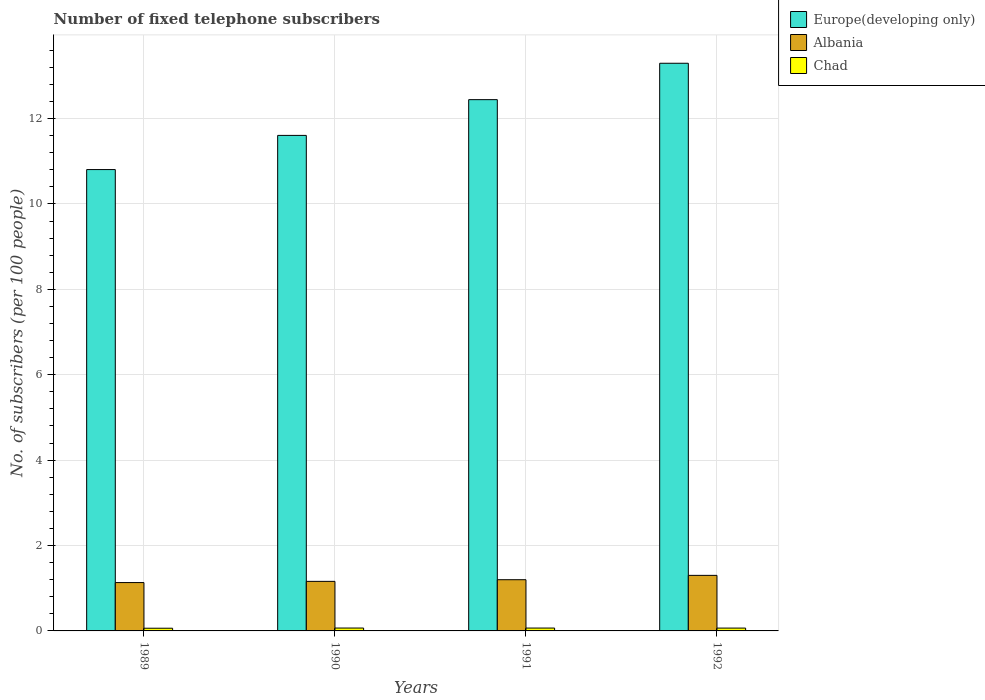How many groups of bars are there?
Offer a terse response. 4. Are the number of bars per tick equal to the number of legend labels?
Provide a short and direct response. Yes. Are the number of bars on each tick of the X-axis equal?
Offer a very short reply. Yes. How many bars are there on the 3rd tick from the left?
Your answer should be very brief. 3. What is the number of fixed telephone subscribers in Albania in 1990?
Your answer should be compact. 1.16. Across all years, what is the maximum number of fixed telephone subscribers in Europe(developing only)?
Provide a succinct answer. 13.29. Across all years, what is the minimum number of fixed telephone subscribers in Chad?
Offer a terse response. 0.06. What is the total number of fixed telephone subscribers in Chad in the graph?
Make the answer very short. 0.26. What is the difference between the number of fixed telephone subscribers in Albania in 1989 and that in 1990?
Give a very brief answer. -0.03. What is the difference between the number of fixed telephone subscribers in Albania in 1991 and the number of fixed telephone subscribers in Chad in 1990?
Offer a terse response. 1.13. What is the average number of fixed telephone subscribers in Europe(developing only) per year?
Your answer should be very brief. 12.04. In the year 1989, what is the difference between the number of fixed telephone subscribers in Albania and number of fixed telephone subscribers in Europe(developing only)?
Offer a terse response. -9.67. In how many years, is the number of fixed telephone subscribers in Chad greater than 2.4?
Make the answer very short. 0. What is the ratio of the number of fixed telephone subscribers in Albania in 1991 to that in 1992?
Your response must be concise. 0.92. Is the difference between the number of fixed telephone subscribers in Albania in 1989 and 1991 greater than the difference between the number of fixed telephone subscribers in Europe(developing only) in 1989 and 1991?
Keep it short and to the point. Yes. What is the difference between the highest and the second highest number of fixed telephone subscribers in Europe(developing only)?
Provide a short and direct response. 0.85. What is the difference between the highest and the lowest number of fixed telephone subscribers in Chad?
Offer a very short reply. 0. What does the 3rd bar from the left in 1989 represents?
Provide a short and direct response. Chad. What does the 1st bar from the right in 1990 represents?
Your answer should be compact. Chad. Is it the case that in every year, the sum of the number of fixed telephone subscribers in Chad and number of fixed telephone subscribers in Europe(developing only) is greater than the number of fixed telephone subscribers in Albania?
Offer a terse response. Yes. How many years are there in the graph?
Offer a terse response. 4. What is the difference between two consecutive major ticks on the Y-axis?
Make the answer very short. 2. Does the graph contain any zero values?
Ensure brevity in your answer.  No. Where does the legend appear in the graph?
Give a very brief answer. Top right. What is the title of the graph?
Make the answer very short. Number of fixed telephone subscribers. Does "Cabo Verde" appear as one of the legend labels in the graph?
Your answer should be very brief. No. What is the label or title of the Y-axis?
Your answer should be very brief. No. of subscribers (per 100 people). What is the No. of subscribers (per 100 people) of Europe(developing only) in 1989?
Keep it short and to the point. 10.8. What is the No. of subscribers (per 100 people) in Albania in 1989?
Offer a very short reply. 1.13. What is the No. of subscribers (per 100 people) of Chad in 1989?
Your answer should be compact. 0.06. What is the No. of subscribers (per 100 people) in Europe(developing only) in 1990?
Provide a short and direct response. 11.61. What is the No. of subscribers (per 100 people) of Albania in 1990?
Your response must be concise. 1.16. What is the No. of subscribers (per 100 people) in Chad in 1990?
Give a very brief answer. 0.07. What is the No. of subscribers (per 100 people) of Europe(developing only) in 1991?
Give a very brief answer. 12.44. What is the No. of subscribers (per 100 people) of Albania in 1991?
Your answer should be compact. 1.2. What is the No. of subscribers (per 100 people) of Chad in 1991?
Give a very brief answer. 0.07. What is the No. of subscribers (per 100 people) in Europe(developing only) in 1992?
Offer a terse response. 13.29. What is the No. of subscribers (per 100 people) in Albania in 1992?
Provide a short and direct response. 1.3. What is the No. of subscribers (per 100 people) in Chad in 1992?
Your answer should be compact. 0.07. Across all years, what is the maximum No. of subscribers (per 100 people) in Europe(developing only)?
Provide a succinct answer. 13.29. Across all years, what is the maximum No. of subscribers (per 100 people) in Albania?
Give a very brief answer. 1.3. Across all years, what is the maximum No. of subscribers (per 100 people) in Chad?
Give a very brief answer. 0.07. Across all years, what is the minimum No. of subscribers (per 100 people) in Europe(developing only)?
Provide a succinct answer. 10.8. Across all years, what is the minimum No. of subscribers (per 100 people) in Albania?
Keep it short and to the point. 1.13. Across all years, what is the minimum No. of subscribers (per 100 people) in Chad?
Give a very brief answer. 0.06. What is the total No. of subscribers (per 100 people) in Europe(developing only) in the graph?
Keep it short and to the point. 48.15. What is the total No. of subscribers (per 100 people) in Albania in the graph?
Offer a terse response. 4.79. What is the total No. of subscribers (per 100 people) in Chad in the graph?
Offer a very short reply. 0.26. What is the difference between the No. of subscribers (per 100 people) in Europe(developing only) in 1989 and that in 1990?
Keep it short and to the point. -0.8. What is the difference between the No. of subscribers (per 100 people) in Albania in 1989 and that in 1990?
Give a very brief answer. -0.03. What is the difference between the No. of subscribers (per 100 people) in Chad in 1989 and that in 1990?
Your answer should be compact. -0. What is the difference between the No. of subscribers (per 100 people) in Europe(developing only) in 1989 and that in 1991?
Make the answer very short. -1.64. What is the difference between the No. of subscribers (per 100 people) of Albania in 1989 and that in 1991?
Offer a very short reply. -0.07. What is the difference between the No. of subscribers (per 100 people) of Chad in 1989 and that in 1991?
Ensure brevity in your answer.  -0. What is the difference between the No. of subscribers (per 100 people) of Europe(developing only) in 1989 and that in 1992?
Your answer should be very brief. -2.49. What is the difference between the No. of subscribers (per 100 people) of Albania in 1989 and that in 1992?
Your answer should be very brief. -0.17. What is the difference between the No. of subscribers (per 100 people) in Chad in 1989 and that in 1992?
Make the answer very short. -0. What is the difference between the No. of subscribers (per 100 people) of Europe(developing only) in 1990 and that in 1991?
Offer a terse response. -0.84. What is the difference between the No. of subscribers (per 100 people) in Albania in 1990 and that in 1991?
Provide a succinct answer. -0.04. What is the difference between the No. of subscribers (per 100 people) of Chad in 1990 and that in 1991?
Offer a very short reply. 0. What is the difference between the No. of subscribers (per 100 people) in Europe(developing only) in 1990 and that in 1992?
Make the answer very short. -1.69. What is the difference between the No. of subscribers (per 100 people) of Albania in 1990 and that in 1992?
Keep it short and to the point. -0.14. What is the difference between the No. of subscribers (per 100 people) of Chad in 1990 and that in 1992?
Your answer should be very brief. 0. What is the difference between the No. of subscribers (per 100 people) in Europe(developing only) in 1991 and that in 1992?
Ensure brevity in your answer.  -0.85. What is the difference between the No. of subscribers (per 100 people) of Albania in 1991 and that in 1992?
Offer a terse response. -0.1. What is the difference between the No. of subscribers (per 100 people) of Chad in 1991 and that in 1992?
Keep it short and to the point. 0. What is the difference between the No. of subscribers (per 100 people) of Europe(developing only) in 1989 and the No. of subscribers (per 100 people) of Albania in 1990?
Give a very brief answer. 9.64. What is the difference between the No. of subscribers (per 100 people) of Europe(developing only) in 1989 and the No. of subscribers (per 100 people) of Chad in 1990?
Ensure brevity in your answer.  10.74. What is the difference between the No. of subscribers (per 100 people) of Albania in 1989 and the No. of subscribers (per 100 people) of Chad in 1990?
Make the answer very short. 1.06. What is the difference between the No. of subscribers (per 100 people) of Europe(developing only) in 1989 and the No. of subscribers (per 100 people) of Albania in 1991?
Offer a terse response. 9.61. What is the difference between the No. of subscribers (per 100 people) in Europe(developing only) in 1989 and the No. of subscribers (per 100 people) in Chad in 1991?
Ensure brevity in your answer.  10.74. What is the difference between the No. of subscribers (per 100 people) in Albania in 1989 and the No. of subscribers (per 100 people) in Chad in 1991?
Offer a terse response. 1.07. What is the difference between the No. of subscribers (per 100 people) in Europe(developing only) in 1989 and the No. of subscribers (per 100 people) in Albania in 1992?
Make the answer very short. 9.5. What is the difference between the No. of subscribers (per 100 people) in Europe(developing only) in 1989 and the No. of subscribers (per 100 people) in Chad in 1992?
Ensure brevity in your answer.  10.74. What is the difference between the No. of subscribers (per 100 people) of Albania in 1989 and the No. of subscribers (per 100 people) of Chad in 1992?
Keep it short and to the point. 1.07. What is the difference between the No. of subscribers (per 100 people) of Europe(developing only) in 1990 and the No. of subscribers (per 100 people) of Albania in 1991?
Offer a terse response. 10.41. What is the difference between the No. of subscribers (per 100 people) of Europe(developing only) in 1990 and the No. of subscribers (per 100 people) of Chad in 1991?
Offer a terse response. 11.54. What is the difference between the No. of subscribers (per 100 people) of Albania in 1990 and the No. of subscribers (per 100 people) of Chad in 1991?
Your answer should be very brief. 1.09. What is the difference between the No. of subscribers (per 100 people) of Europe(developing only) in 1990 and the No. of subscribers (per 100 people) of Albania in 1992?
Your answer should be compact. 10.3. What is the difference between the No. of subscribers (per 100 people) in Europe(developing only) in 1990 and the No. of subscribers (per 100 people) in Chad in 1992?
Give a very brief answer. 11.54. What is the difference between the No. of subscribers (per 100 people) in Albania in 1990 and the No. of subscribers (per 100 people) in Chad in 1992?
Your response must be concise. 1.09. What is the difference between the No. of subscribers (per 100 people) in Europe(developing only) in 1991 and the No. of subscribers (per 100 people) in Albania in 1992?
Your answer should be compact. 11.14. What is the difference between the No. of subscribers (per 100 people) of Europe(developing only) in 1991 and the No. of subscribers (per 100 people) of Chad in 1992?
Keep it short and to the point. 12.38. What is the difference between the No. of subscribers (per 100 people) of Albania in 1991 and the No. of subscribers (per 100 people) of Chad in 1992?
Keep it short and to the point. 1.13. What is the average No. of subscribers (per 100 people) in Europe(developing only) per year?
Provide a succinct answer. 12.04. What is the average No. of subscribers (per 100 people) of Albania per year?
Make the answer very short. 1.2. What is the average No. of subscribers (per 100 people) of Chad per year?
Offer a terse response. 0.07. In the year 1989, what is the difference between the No. of subscribers (per 100 people) of Europe(developing only) and No. of subscribers (per 100 people) of Albania?
Make the answer very short. 9.67. In the year 1989, what is the difference between the No. of subscribers (per 100 people) of Europe(developing only) and No. of subscribers (per 100 people) of Chad?
Provide a succinct answer. 10.74. In the year 1989, what is the difference between the No. of subscribers (per 100 people) in Albania and No. of subscribers (per 100 people) in Chad?
Give a very brief answer. 1.07. In the year 1990, what is the difference between the No. of subscribers (per 100 people) in Europe(developing only) and No. of subscribers (per 100 people) in Albania?
Your answer should be compact. 10.44. In the year 1990, what is the difference between the No. of subscribers (per 100 people) of Europe(developing only) and No. of subscribers (per 100 people) of Chad?
Make the answer very short. 11.54. In the year 1990, what is the difference between the No. of subscribers (per 100 people) of Albania and No. of subscribers (per 100 people) of Chad?
Your answer should be compact. 1.09. In the year 1991, what is the difference between the No. of subscribers (per 100 people) in Europe(developing only) and No. of subscribers (per 100 people) in Albania?
Provide a short and direct response. 11.24. In the year 1991, what is the difference between the No. of subscribers (per 100 people) in Europe(developing only) and No. of subscribers (per 100 people) in Chad?
Offer a very short reply. 12.38. In the year 1991, what is the difference between the No. of subscribers (per 100 people) in Albania and No. of subscribers (per 100 people) in Chad?
Your answer should be very brief. 1.13. In the year 1992, what is the difference between the No. of subscribers (per 100 people) in Europe(developing only) and No. of subscribers (per 100 people) in Albania?
Your answer should be very brief. 11.99. In the year 1992, what is the difference between the No. of subscribers (per 100 people) of Europe(developing only) and No. of subscribers (per 100 people) of Chad?
Offer a terse response. 13.23. In the year 1992, what is the difference between the No. of subscribers (per 100 people) in Albania and No. of subscribers (per 100 people) in Chad?
Offer a terse response. 1.23. What is the ratio of the No. of subscribers (per 100 people) in Albania in 1989 to that in 1990?
Your response must be concise. 0.98. What is the ratio of the No. of subscribers (per 100 people) in Chad in 1989 to that in 1990?
Your answer should be compact. 0.93. What is the ratio of the No. of subscribers (per 100 people) in Europe(developing only) in 1989 to that in 1991?
Your response must be concise. 0.87. What is the ratio of the No. of subscribers (per 100 people) in Albania in 1989 to that in 1991?
Provide a succinct answer. 0.94. What is the ratio of the No. of subscribers (per 100 people) in Chad in 1989 to that in 1991?
Give a very brief answer. 0.94. What is the ratio of the No. of subscribers (per 100 people) of Europe(developing only) in 1989 to that in 1992?
Give a very brief answer. 0.81. What is the ratio of the No. of subscribers (per 100 people) in Albania in 1989 to that in 1992?
Your response must be concise. 0.87. What is the ratio of the No. of subscribers (per 100 people) in Chad in 1989 to that in 1992?
Offer a terse response. 0.95. What is the ratio of the No. of subscribers (per 100 people) of Europe(developing only) in 1990 to that in 1991?
Give a very brief answer. 0.93. What is the ratio of the No. of subscribers (per 100 people) in Albania in 1990 to that in 1991?
Offer a terse response. 0.97. What is the ratio of the No. of subscribers (per 100 people) of Chad in 1990 to that in 1991?
Offer a very short reply. 1.01. What is the ratio of the No. of subscribers (per 100 people) in Europe(developing only) in 1990 to that in 1992?
Give a very brief answer. 0.87. What is the ratio of the No. of subscribers (per 100 people) in Albania in 1990 to that in 1992?
Provide a succinct answer. 0.89. What is the ratio of the No. of subscribers (per 100 people) of Chad in 1990 to that in 1992?
Provide a succinct answer. 1.02. What is the ratio of the No. of subscribers (per 100 people) in Europe(developing only) in 1991 to that in 1992?
Your response must be concise. 0.94. What is the ratio of the No. of subscribers (per 100 people) of Albania in 1991 to that in 1992?
Ensure brevity in your answer.  0.92. What is the ratio of the No. of subscribers (per 100 people) of Chad in 1991 to that in 1992?
Provide a succinct answer. 1.01. What is the difference between the highest and the second highest No. of subscribers (per 100 people) in Europe(developing only)?
Make the answer very short. 0.85. What is the difference between the highest and the second highest No. of subscribers (per 100 people) of Albania?
Give a very brief answer. 0.1. What is the difference between the highest and the second highest No. of subscribers (per 100 people) of Chad?
Keep it short and to the point. 0. What is the difference between the highest and the lowest No. of subscribers (per 100 people) in Europe(developing only)?
Provide a short and direct response. 2.49. What is the difference between the highest and the lowest No. of subscribers (per 100 people) of Albania?
Ensure brevity in your answer.  0.17. What is the difference between the highest and the lowest No. of subscribers (per 100 people) of Chad?
Keep it short and to the point. 0. 